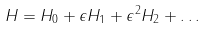<formula> <loc_0><loc_0><loc_500><loc_500>H = H _ { 0 } + \epsilon H _ { 1 } + \epsilon ^ { 2 } H _ { 2 } + \dots</formula> 